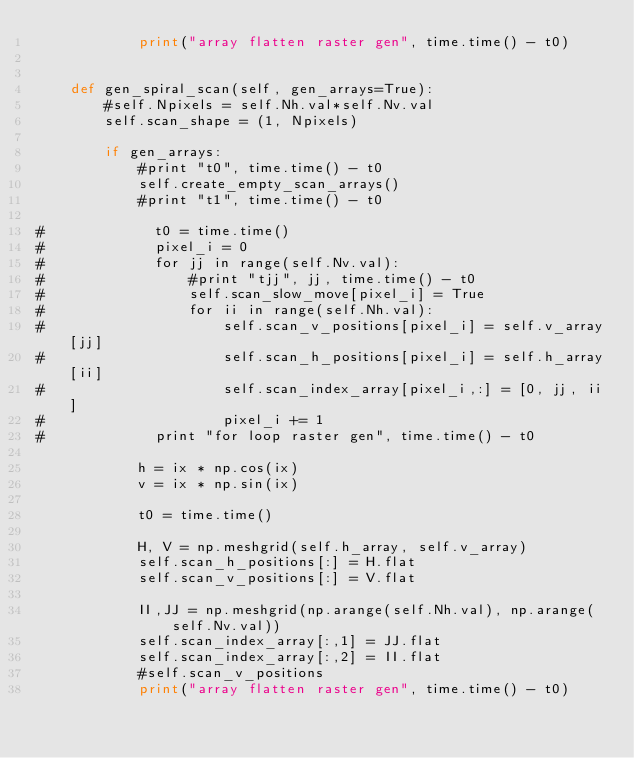Convert code to text. <code><loc_0><loc_0><loc_500><loc_500><_Python_>            print("array flatten raster gen", time.time() - t0)
            
            
    def gen_spiral_scan(self, gen_arrays=True):
        #self.Npixels = self.Nh.val*self.Nv.val
        self.scan_shape = (1, Npixels)
        
        if gen_arrays:
            #print "t0", time.time() - t0
            self.create_empty_scan_arrays()            
            #print "t1", time.time() - t0
            
#             t0 = time.time()
#             pixel_i = 0
#             for jj in range(self.Nv.val):
#                 #print "tjj", jj, time.time() - t0
#                 self.scan_slow_move[pixel_i] = True
#                 for ii in range(self.Nh.val):
#                     self.scan_v_positions[pixel_i] = self.v_array[jj]
#                     self.scan_h_positions[pixel_i] = self.h_array[ii]
#                     self.scan_index_array[pixel_i,:] = [0, jj, ii] 
#                     pixel_i += 1
#             print "for loop raster gen", time.time() - t0
            
            h = ix * np.cos(ix)
            v = ix * np.sin(ix)
            
            t0 = time.time()
             
            H, V = np.meshgrid(self.h_array, self.v_array)
            self.scan_h_positions[:] = H.flat
            self.scan_v_positions[:] = V.flat
            
            II,JJ = np.meshgrid(np.arange(self.Nh.val), np.arange(self.Nv.val))
            self.scan_index_array[:,1] = JJ.flat
            self.scan_index_array[:,2] = II.flat
            #self.scan_v_positions
            print("array flatten raster gen", time.time() - t0)
</code> 